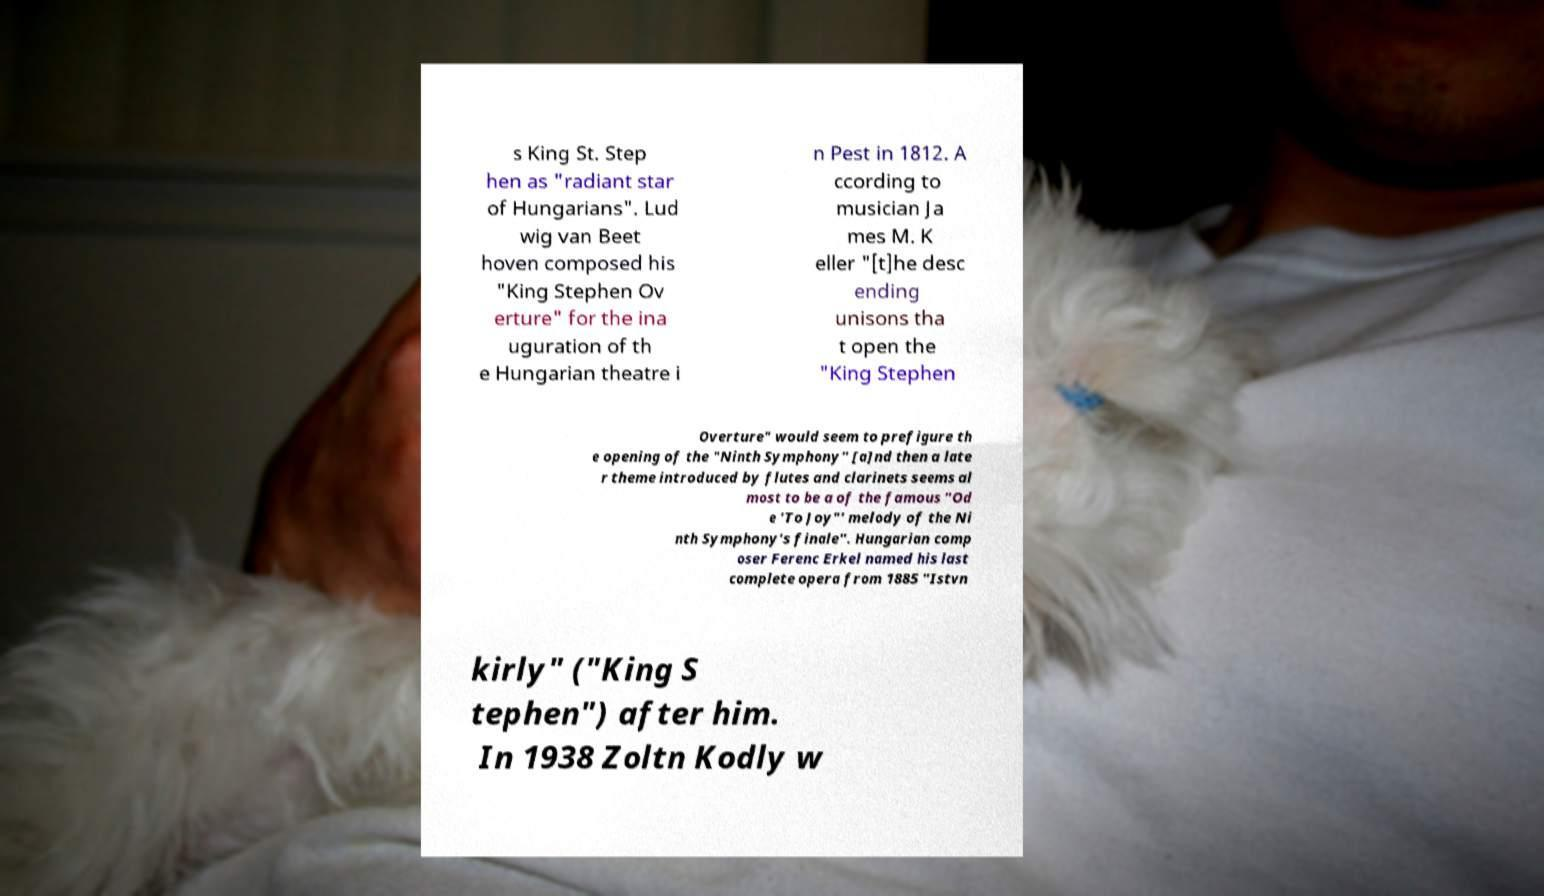Can you accurately transcribe the text from the provided image for me? s King St. Step hen as "radiant star of Hungarians". Lud wig van Beet hoven composed his "King Stephen Ov erture" for the ina uguration of th e Hungarian theatre i n Pest in 1812. A ccording to musician Ja mes M. K eller "[t]he desc ending unisons tha t open the "King Stephen Overture" would seem to prefigure th e opening of the "Ninth Symphony" [a]nd then a late r theme introduced by flutes and clarinets seems al most to be a of the famous "Od e 'To Joy"' melody of the Ni nth Symphony's finale". Hungarian comp oser Ferenc Erkel named his last complete opera from 1885 "Istvn kirly" ("King S tephen") after him. In 1938 Zoltn Kodly w 